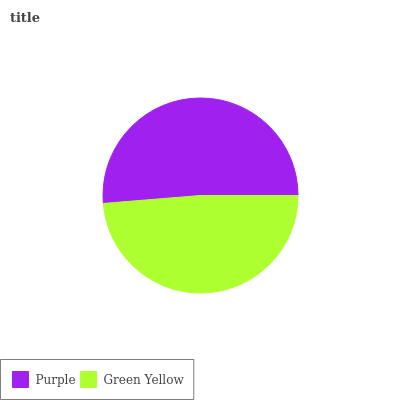Is Green Yellow the minimum?
Answer yes or no. Yes. Is Purple the maximum?
Answer yes or no. Yes. Is Green Yellow the maximum?
Answer yes or no. No. Is Purple greater than Green Yellow?
Answer yes or no. Yes. Is Green Yellow less than Purple?
Answer yes or no. Yes. Is Green Yellow greater than Purple?
Answer yes or no. No. Is Purple less than Green Yellow?
Answer yes or no. No. Is Purple the high median?
Answer yes or no. Yes. Is Green Yellow the low median?
Answer yes or no. Yes. Is Green Yellow the high median?
Answer yes or no. No. Is Purple the low median?
Answer yes or no. No. 